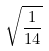<formula> <loc_0><loc_0><loc_500><loc_500>\sqrt { \frac { 1 } { 1 4 } }</formula> 